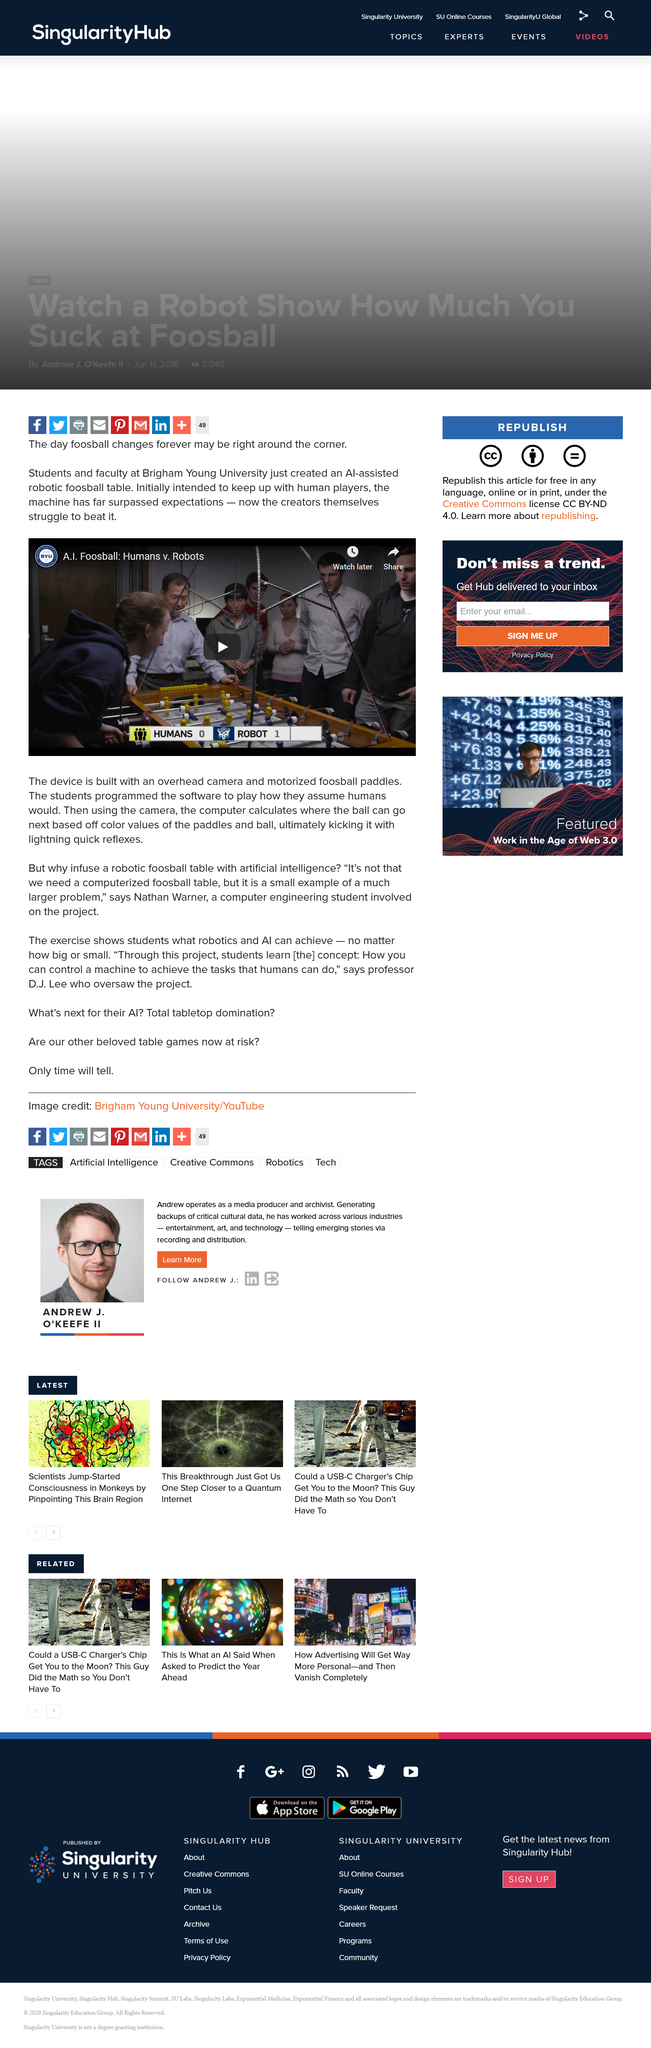Point out several critical features in this image. The A.I. assisted robotic foosball table was programmed by the students from Brigham Young University. The device is constructed with an overhead camera and motorized foosball paddles in order to facilitate accurate tracking and user interaction. The score in the game being played in the image is currently 0 for the humans and 1 for the robots. 